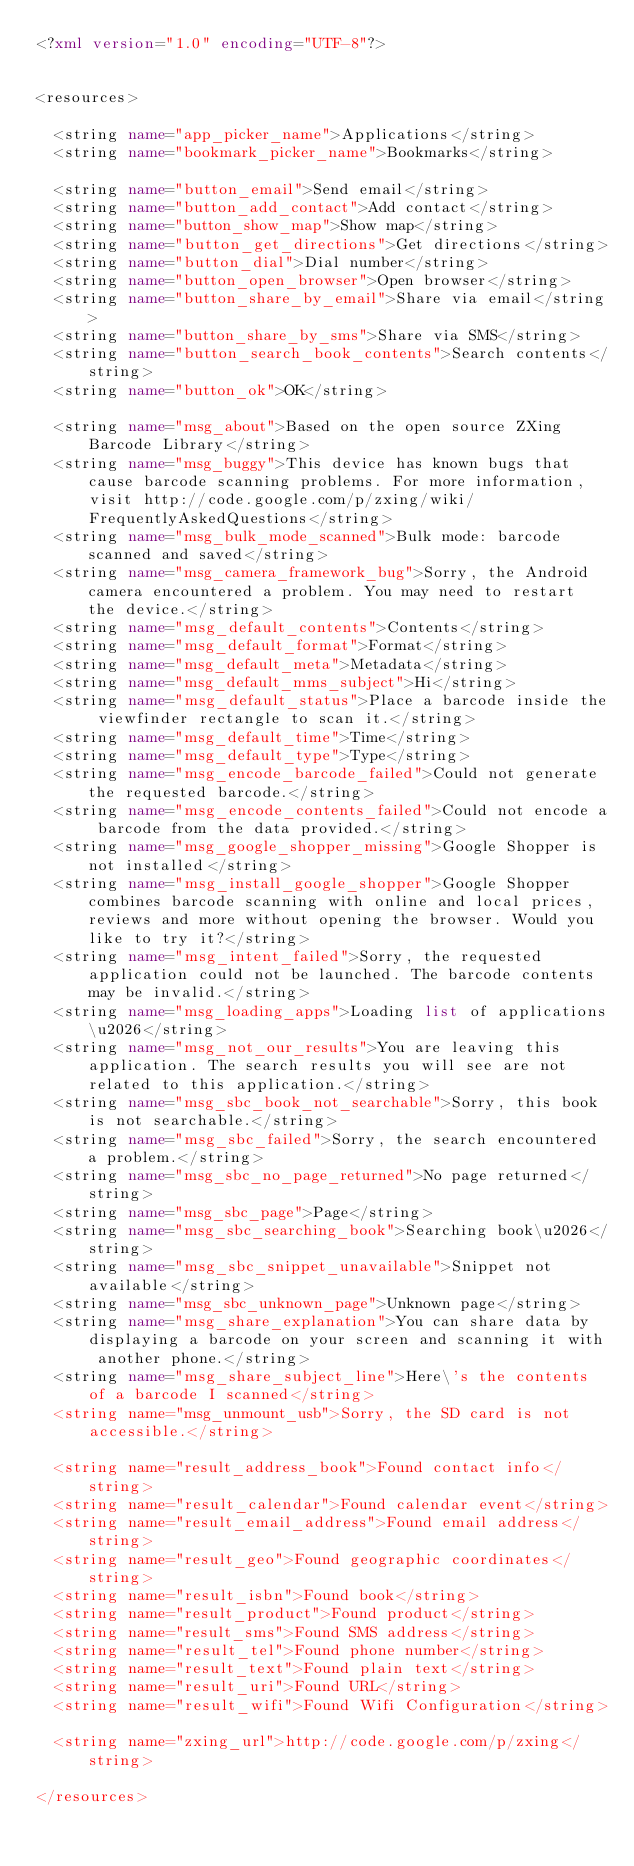<code> <loc_0><loc_0><loc_500><loc_500><_XML_><?xml version="1.0" encoding="UTF-8"?>


<resources>

  <string name="app_picker_name">Applications</string>
  <string name="bookmark_picker_name">Bookmarks</string>
  
  <string name="button_email">Send email</string>
  <string name="button_add_contact">Add contact</string>
  <string name="button_show_map">Show map</string>
  <string name="button_get_directions">Get directions</string>
  <string name="button_dial">Dial number</string>
  <string name="button_open_browser">Open browser</string>
  <string name="button_share_by_email">Share via email</string>
  <string name="button_share_by_sms">Share via SMS</string>
  <string name="button_search_book_contents">Search contents</string>
  <string name="button_ok">OK</string>
  
  <string name="msg_about">Based on the open source ZXing Barcode Library</string>
  <string name="msg_buggy">This device has known bugs that cause barcode scanning problems. For more information, visit http://code.google.com/p/zxing/wiki/FrequentlyAskedQuestions</string>
  <string name="msg_bulk_mode_scanned">Bulk mode: barcode scanned and saved</string>
  <string name="msg_camera_framework_bug">Sorry, the Android camera encountered a problem. You may need to restart the device.</string>
  <string name="msg_default_contents">Contents</string>
  <string name="msg_default_format">Format</string>
  <string name="msg_default_meta">Metadata</string>
  <string name="msg_default_mms_subject">Hi</string>
  <string name="msg_default_status">Place a barcode inside the viewfinder rectangle to scan it.</string>
  <string name="msg_default_time">Time</string>
  <string name="msg_default_type">Type</string>
  <string name="msg_encode_barcode_failed">Could not generate the requested barcode.</string>
  <string name="msg_encode_contents_failed">Could not encode a barcode from the data provided.</string>
  <string name="msg_google_shopper_missing">Google Shopper is not installed</string>
  <string name="msg_install_google_shopper">Google Shopper combines barcode scanning with online and local prices, reviews and more without opening the browser. Would you like to try it?</string>
  <string name="msg_intent_failed">Sorry, the requested application could not be launched. The barcode contents may be invalid.</string>
  <string name="msg_loading_apps">Loading list of applications\u2026</string>
  <string name="msg_not_our_results">You are leaving this application. The search results you will see are not related to this application.</string>
  <string name="msg_sbc_book_not_searchable">Sorry, this book is not searchable.</string>
  <string name="msg_sbc_failed">Sorry, the search encountered a problem.</string>
  <string name="msg_sbc_no_page_returned">No page returned</string>
  <string name="msg_sbc_page">Page</string>
  <string name="msg_sbc_searching_book">Searching book\u2026</string>
  <string name="msg_sbc_snippet_unavailable">Snippet not available</string>
  <string name="msg_sbc_unknown_page">Unknown page</string>
  <string name="msg_share_explanation">You can share data by displaying a barcode on your screen and scanning it with another phone.</string>
  <string name="msg_share_subject_line">Here\'s the contents of a barcode I scanned</string>
  <string name="msg_unmount_usb">Sorry, the SD card is not accessible.</string>
  
  <string name="result_address_book">Found contact info</string>
  <string name="result_calendar">Found calendar event</string>
  <string name="result_email_address">Found email address</string>
  <string name="result_geo">Found geographic coordinates</string>
  <string name="result_isbn">Found book</string>
  <string name="result_product">Found product</string>
  <string name="result_sms">Found SMS address</string>
  <string name="result_tel">Found phone number</string>
  <string name="result_text">Found plain text</string>
  <string name="result_uri">Found URL</string>
  <string name="result_wifi">Found Wifi Configuration</string>
  
  <string name="zxing_url">http://code.google.com/p/zxing</string>
  
</resources>
</code> 